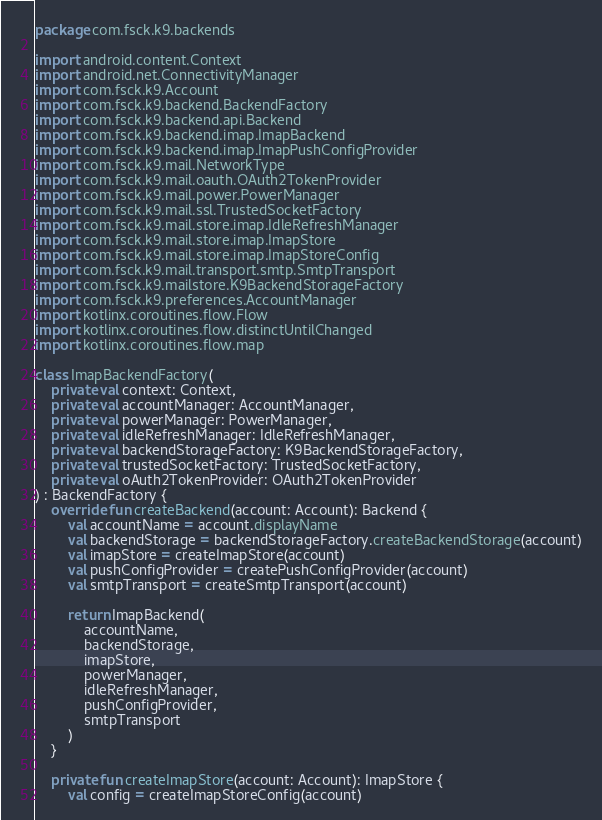Convert code to text. <code><loc_0><loc_0><loc_500><loc_500><_Kotlin_>package com.fsck.k9.backends

import android.content.Context
import android.net.ConnectivityManager
import com.fsck.k9.Account
import com.fsck.k9.backend.BackendFactory
import com.fsck.k9.backend.api.Backend
import com.fsck.k9.backend.imap.ImapBackend
import com.fsck.k9.backend.imap.ImapPushConfigProvider
import com.fsck.k9.mail.NetworkType
import com.fsck.k9.mail.oauth.OAuth2TokenProvider
import com.fsck.k9.mail.power.PowerManager
import com.fsck.k9.mail.ssl.TrustedSocketFactory
import com.fsck.k9.mail.store.imap.IdleRefreshManager
import com.fsck.k9.mail.store.imap.ImapStore
import com.fsck.k9.mail.store.imap.ImapStoreConfig
import com.fsck.k9.mail.transport.smtp.SmtpTransport
import com.fsck.k9.mailstore.K9BackendStorageFactory
import com.fsck.k9.preferences.AccountManager
import kotlinx.coroutines.flow.Flow
import kotlinx.coroutines.flow.distinctUntilChanged
import kotlinx.coroutines.flow.map

class ImapBackendFactory(
    private val context: Context,
    private val accountManager: AccountManager,
    private val powerManager: PowerManager,
    private val idleRefreshManager: IdleRefreshManager,
    private val backendStorageFactory: K9BackendStorageFactory,
    private val trustedSocketFactory: TrustedSocketFactory,
    private val oAuth2TokenProvider: OAuth2TokenProvider
) : BackendFactory {
    override fun createBackend(account: Account): Backend {
        val accountName = account.displayName
        val backendStorage = backendStorageFactory.createBackendStorage(account)
        val imapStore = createImapStore(account)
        val pushConfigProvider = createPushConfigProvider(account)
        val smtpTransport = createSmtpTransport(account)

        return ImapBackend(
            accountName,
            backendStorage,
            imapStore,
            powerManager,
            idleRefreshManager,
            pushConfigProvider,
            smtpTransport
        )
    }

    private fun createImapStore(account: Account): ImapStore {
        val config = createImapStoreConfig(account)</code> 